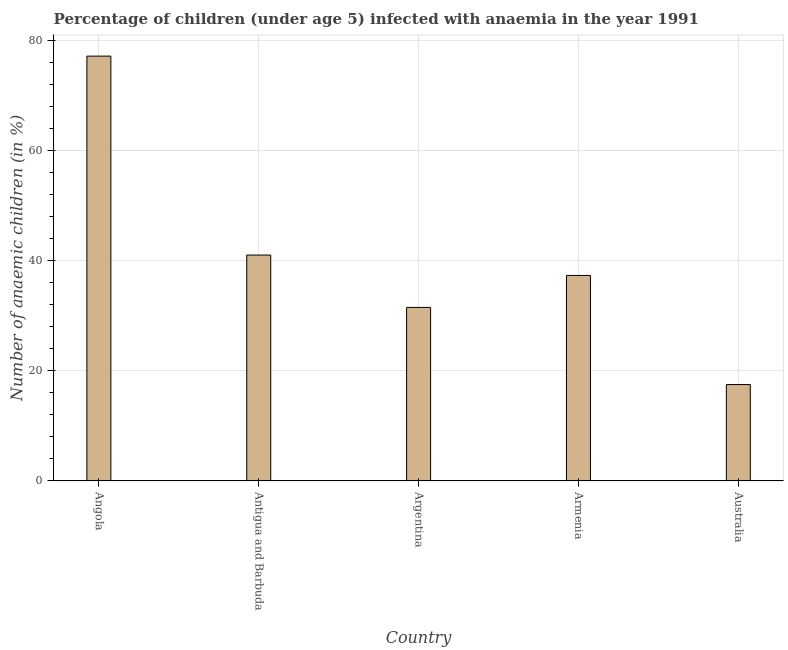Does the graph contain any zero values?
Provide a short and direct response. No. What is the title of the graph?
Your answer should be compact. Percentage of children (under age 5) infected with anaemia in the year 1991. What is the label or title of the Y-axis?
Ensure brevity in your answer.  Number of anaemic children (in %). What is the number of anaemic children in Angola?
Make the answer very short. 77.1. Across all countries, what is the maximum number of anaemic children?
Ensure brevity in your answer.  77.1. Across all countries, what is the minimum number of anaemic children?
Offer a terse response. 17.5. In which country was the number of anaemic children maximum?
Give a very brief answer. Angola. What is the sum of the number of anaemic children?
Ensure brevity in your answer.  204.4. What is the average number of anaemic children per country?
Your response must be concise. 40.88. What is the median number of anaemic children?
Your answer should be compact. 37.3. What is the ratio of the number of anaemic children in Angola to that in Antigua and Barbuda?
Make the answer very short. 1.88. What is the difference between the highest and the second highest number of anaemic children?
Offer a terse response. 36.1. What is the difference between the highest and the lowest number of anaemic children?
Ensure brevity in your answer.  59.6. In how many countries, is the number of anaemic children greater than the average number of anaemic children taken over all countries?
Offer a very short reply. 2. Are all the bars in the graph horizontal?
Offer a terse response. No. What is the Number of anaemic children (in %) in Angola?
Offer a terse response. 77.1. What is the Number of anaemic children (in %) in Argentina?
Provide a succinct answer. 31.5. What is the Number of anaemic children (in %) in Armenia?
Keep it short and to the point. 37.3. What is the Number of anaemic children (in %) in Australia?
Provide a succinct answer. 17.5. What is the difference between the Number of anaemic children (in %) in Angola and Antigua and Barbuda?
Your response must be concise. 36.1. What is the difference between the Number of anaemic children (in %) in Angola and Argentina?
Offer a terse response. 45.6. What is the difference between the Number of anaemic children (in %) in Angola and Armenia?
Provide a succinct answer. 39.8. What is the difference between the Number of anaemic children (in %) in Angola and Australia?
Ensure brevity in your answer.  59.6. What is the difference between the Number of anaemic children (in %) in Antigua and Barbuda and Argentina?
Provide a short and direct response. 9.5. What is the difference between the Number of anaemic children (in %) in Antigua and Barbuda and Australia?
Your answer should be compact. 23.5. What is the difference between the Number of anaemic children (in %) in Argentina and Armenia?
Your response must be concise. -5.8. What is the difference between the Number of anaemic children (in %) in Argentina and Australia?
Your answer should be compact. 14. What is the difference between the Number of anaemic children (in %) in Armenia and Australia?
Give a very brief answer. 19.8. What is the ratio of the Number of anaemic children (in %) in Angola to that in Antigua and Barbuda?
Your answer should be very brief. 1.88. What is the ratio of the Number of anaemic children (in %) in Angola to that in Argentina?
Give a very brief answer. 2.45. What is the ratio of the Number of anaemic children (in %) in Angola to that in Armenia?
Give a very brief answer. 2.07. What is the ratio of the Number of anaemic children (in %) in Angola to that in Australia?
Offer a very short reply. 4.41. What is the ratio of the Number of anaemic children (in %) in Antigua and Barbuda to that in Argentina?
Your answer should be very brief. 1.3. What is the ratio of the Number of anaemic children (in %) in Antigua and Barbuda to that in Armenia?
Your answer should be compact. 1.1. What is the ratio of the Number of anaemic children (in %) in Antigua and Barbuda to that in Australia?
Keep it short and to the point. 2.34. What is the ratio of the Number of anaemic children (in %) in Argentina to that in Armenia?
Your response must be concise. 0.84. What is the ratio of the Number of anaemic children (in %) in Argentina to that in Australia?
Make the answer very short. 1.8. What is the ratio of the Number of anaemic children (in %) in Armenia to that in Australia?
Provide a short and direct response. 2.13. 